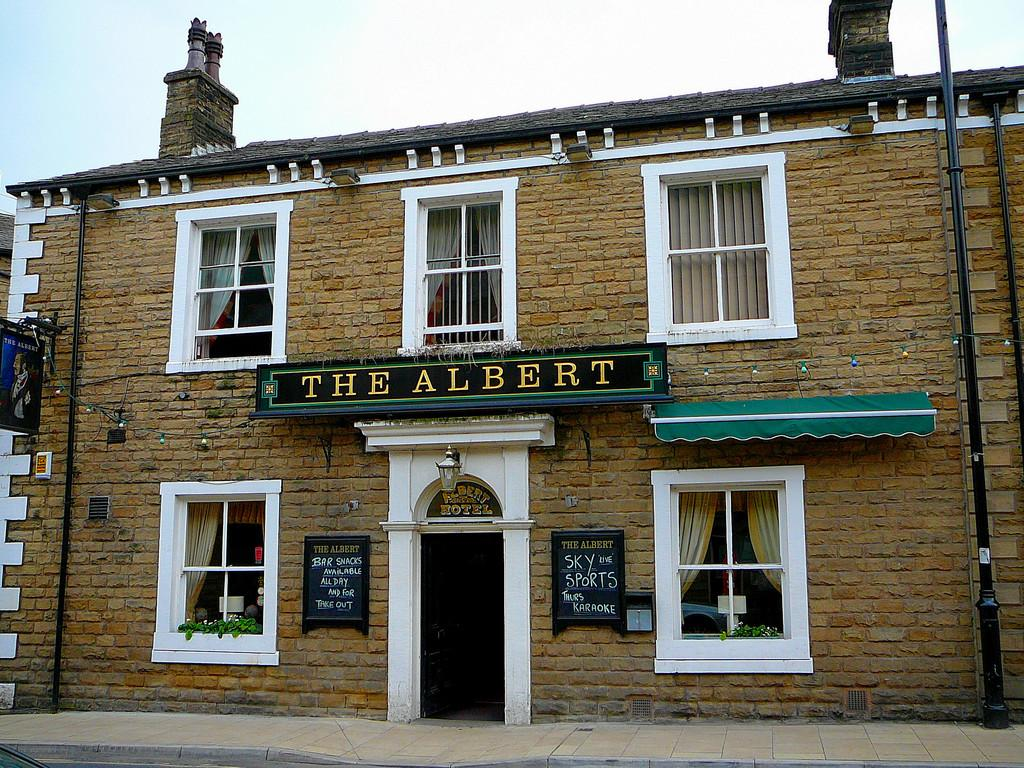What is the main subject of the image? The main subject of the image is a building. What specific features can be observed on the building? The building has windows, and the windows have curtains. Is there any indication of activity inside the building? Yes, there is light visible in the windows, which suggests that there may be activity inside. What is the background of the image? The sky is visible in the background of the image. What rule is being enforced by the cough in the image? There is no cough present in the image, and therefore no rule can be associated with it. 